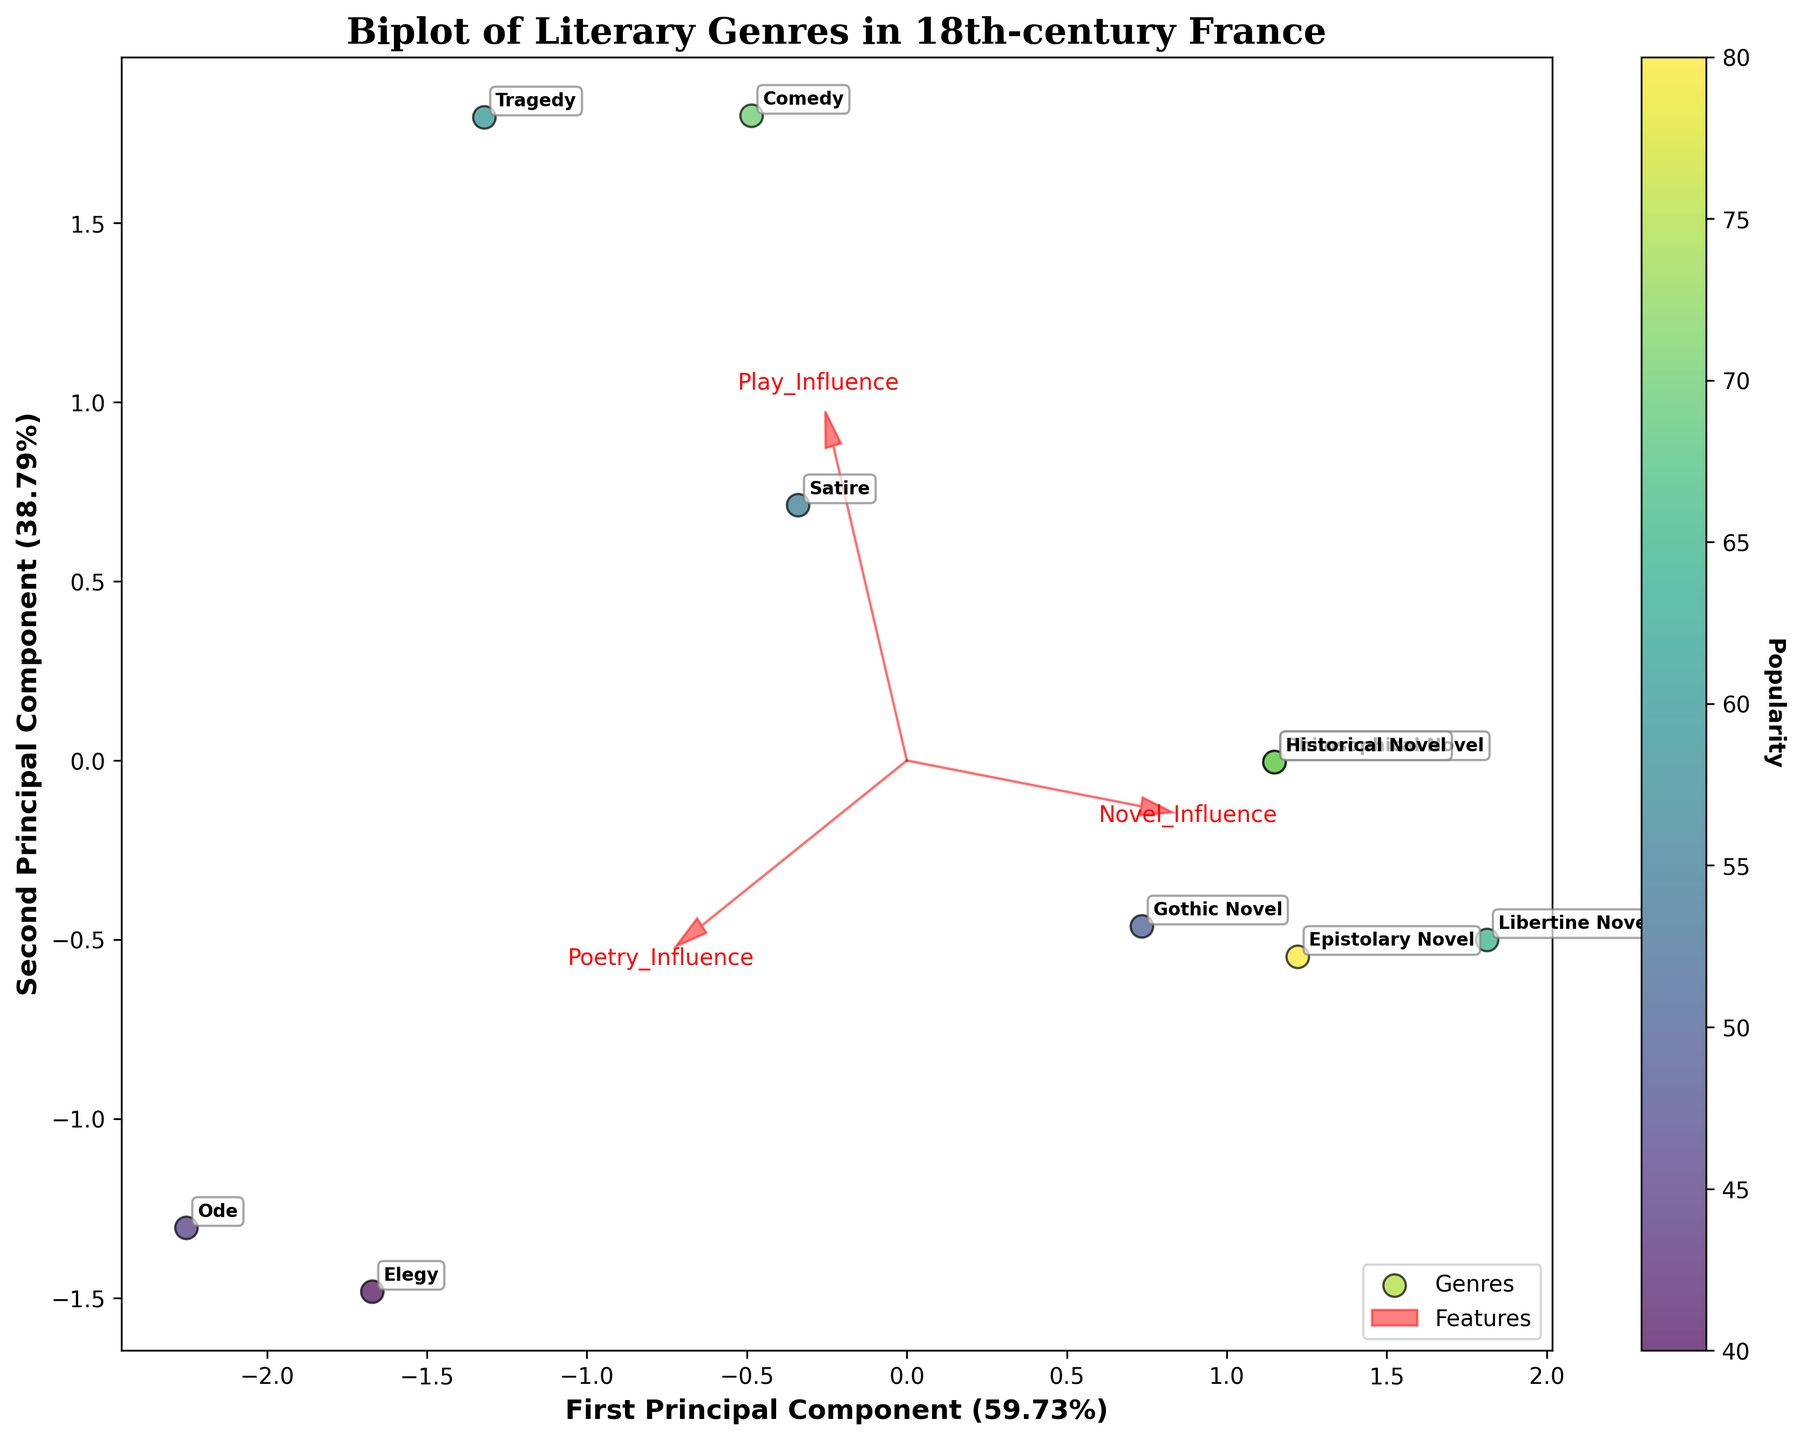Which genre is the most popular? The genre with the highest 'Popularity' value is the 'Epistolary Novel' according to the color bar presented in the figure.
Answer: Epistolary Novel Which genres are clearly influenced by novels? Genres with arrows pointing significantly toward 'Novel_Influence' indicate a strong influence. These genres include 'Philosophical Novel,' 'Libertine Novel,' 'Gothic Novel,' 'Epistolary Novel,' and 'Historical Novel.'
Answer: Philosophical Novel, Libertine Novel, Gothic Novel, Epistolary Novel, Historical Novel Among 'Comedy' and 'Tragedy,' which genre has a higher popularity? By comparing the positions and colors of the dots representing 'Comedy' and 'Tragedy,' 'Comedy' has a higher popularity as indicated by a darker color on the viridis scale.
Answer: Comedy Which genre has the highest combination of 'Play_Influence' and 'Poetry_Influence'? Looking at the projection arrows for 'Play_Influence' and 'Poetry_Influence,' the genre occupying a region influenced by both factors is 'Tragedy.'
Answer: Tragedy How does the 'Ode' genre rank in terms of popularity compared to other genres? By observing the colors from the viridis scale and position on the plot, 'Ode' appears less popular compared to several other genres with lighter colors, such as 'Philosophical Novel' and 'Epistolary Novel.'
Answer: Less popular Which genre seems to be least influenced by novels? The genre closest to the origin (0,0) on the 'Novel_Influence' axis is the 'Ode.'
Answer: Ode Which genre is most influenced by poetry? The arrow for 'Poetry_Influence' points largely towards 'Ode' and 'Elegy,' indicating strong influence by poetry.
Answer: Ode, Elegy What is the relationship between 'Libertine Novel' and 'Gothic Novel' in terms of novel influence? 'Libertine Novel' has a higher 'Novel_Influence' score (0.9) compared to 'Gothic Novel' (0.7), observable by the relative arrow lengths on the biplot.
Answer: Libertine Novel has higher influence Which genre appears closest to the origin in the PCA-transformed space? By observing the plot, the genre closest to the origin (0,0) is 'Elegy,' indicating it has more average influences across all categories.
Answer: Elegy 